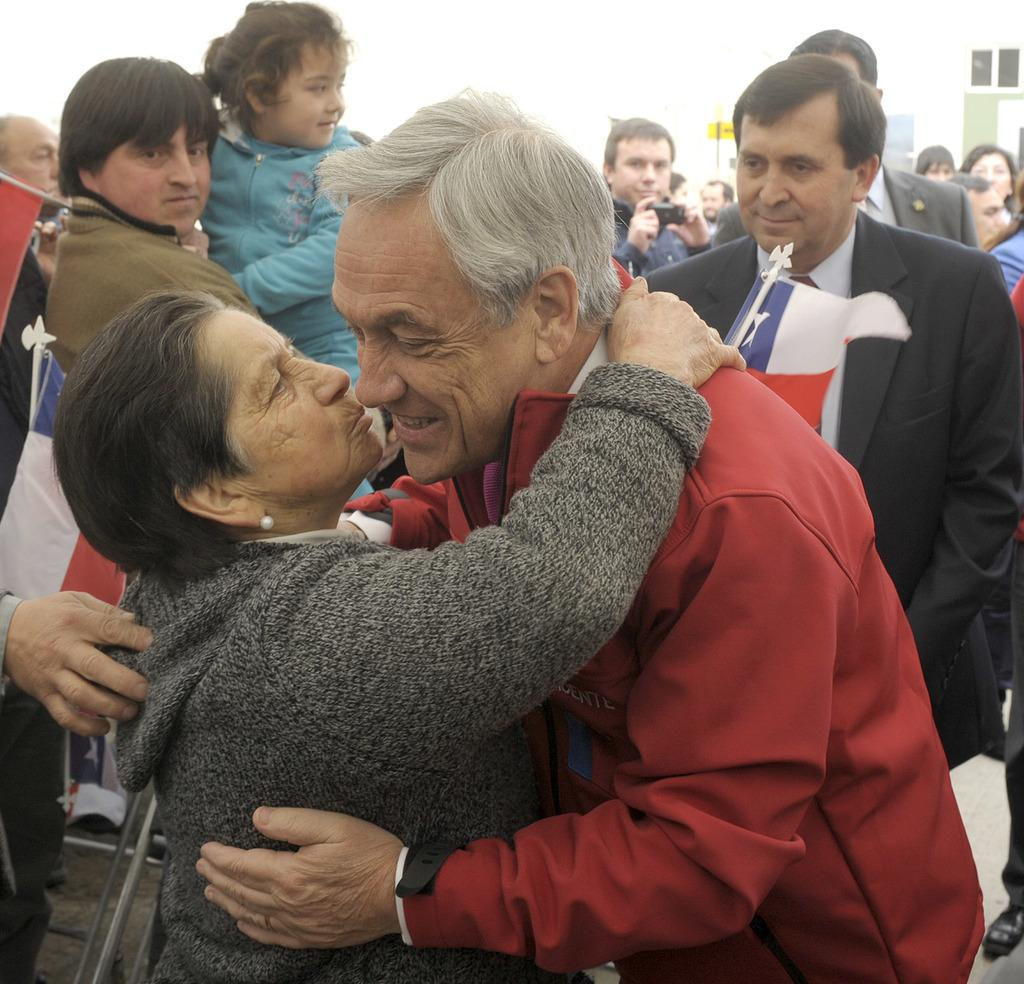What are the two persons in the image doing? The two persons in the image are standing and hugging each other. What can be seen in the background of the image? There are flags and a group of people standing in the background of the image. What type of hat is the person in the image wearing? There is no hat visible on either person in the image. Can you describe how the person in the image is smashing the cake? There is no cake or smashing action present in the image. 